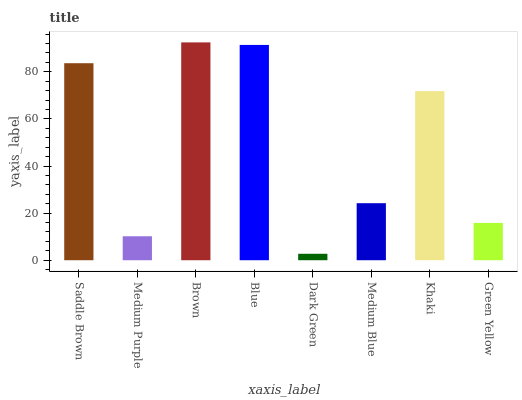Is Medium Purple the minimum?
Answer yes or no. No. Is Medium Purple the maximum?
Answer yes or no. No. Is Saddle Brown greater than Medium Purple?
Answer yes or no. Yes. Is Medium Purple less than Saddle Brown?
Answer yes or no. Yes. Is Medium Purple greater than Saddle Brown?
Answer yes or no. No. Is Saddle Brown less than Medium Purple?
Answer yes or no. No. Is Khaki the high median?
Answer yes or no. Yes. Is Medium Blue the low median?
Answer yes or no. Yes. Is Blue the high median?
Answer yes or no. No. Is Blue the low median?
Answer yes or no. No. 